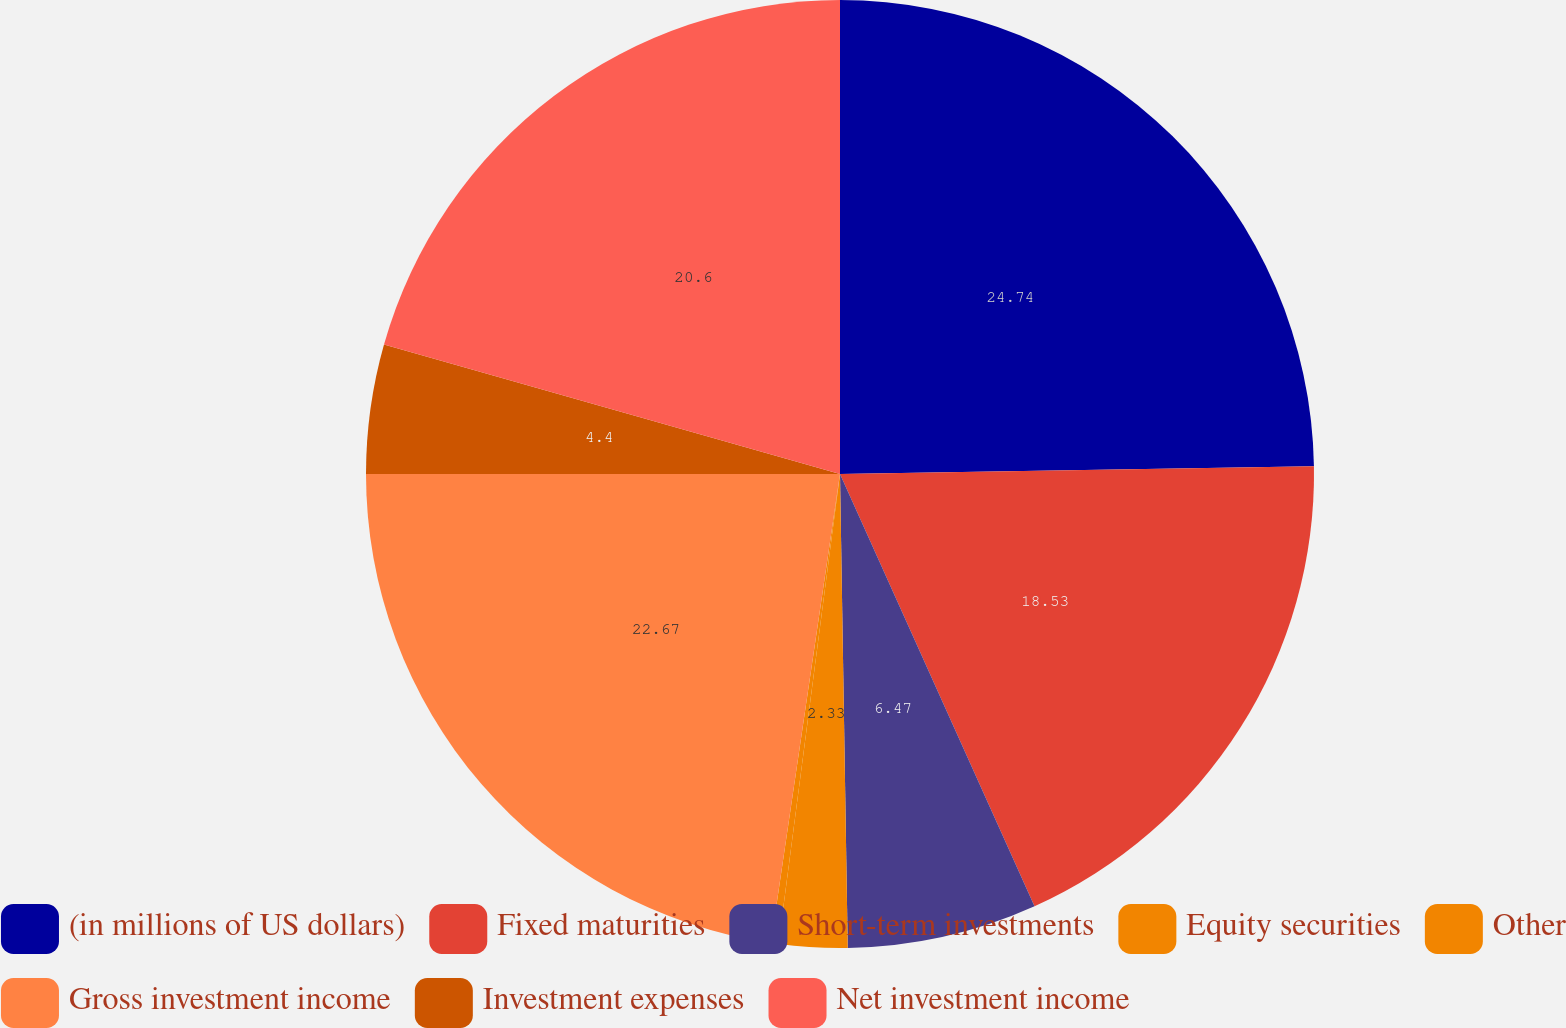Convert chart to OTSL. <chart><loc_0><loc_0><loc_500><loc_500><pie_chart><fcel>(in millions of US dollars)<fcel>Fixed maturities<fcel>Short-term investments<fcel>Equity securities<fcel>Other<fcel>Gross investment income<fcel>Investment expenses<fcel>Net investment income<nl><fcel>24.74%<fcel>18.53%<fcel>6.47%<fcel>2.33%<fcel>0.26%<fcel>22.67%<fcel>4.4%<fcel>20.6%<nl></chart> 